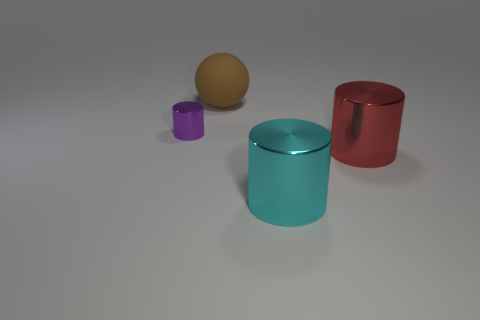Is there any other thing that has the same size as the purple metallic cylinder?
Your answer should be very brief. No. How many things are either small brown matte cylinders or metallic things?
Your answer should be very brief. 3. What number of big red things are in front of the cylinder that is left of the big thing behind the purple cylinder?
Ensure brevity in your answer.  1. There is a cyan object that is the same shape as the large red thing; what is it made of?
Offer a terse response. Metal. There is a big object that is to the left of the red metal cylinder and in front of the big brown object; what material is it?
Your answer should be compact. Metal. Is the number of brown balls behind the brown matte ball less than the number of cyan objects that are behind the small metal cylinder?
Keep it short and to the point. No. How many other things are the same size as the cyan cylinder?
Offer a very short reply. 2. The big object behind the metal cylinder to the left of the big object behind the purple cylinder is what shape?
Keep it short and to the point. Sphere. What number of red things are either matte cylinders or big shiny cylinders?
Provide a succinct answer. 1. What number of tiny purple metal things are in front of the metal object that is to the left of the big matte ball?
Offer a terse response. 0. 